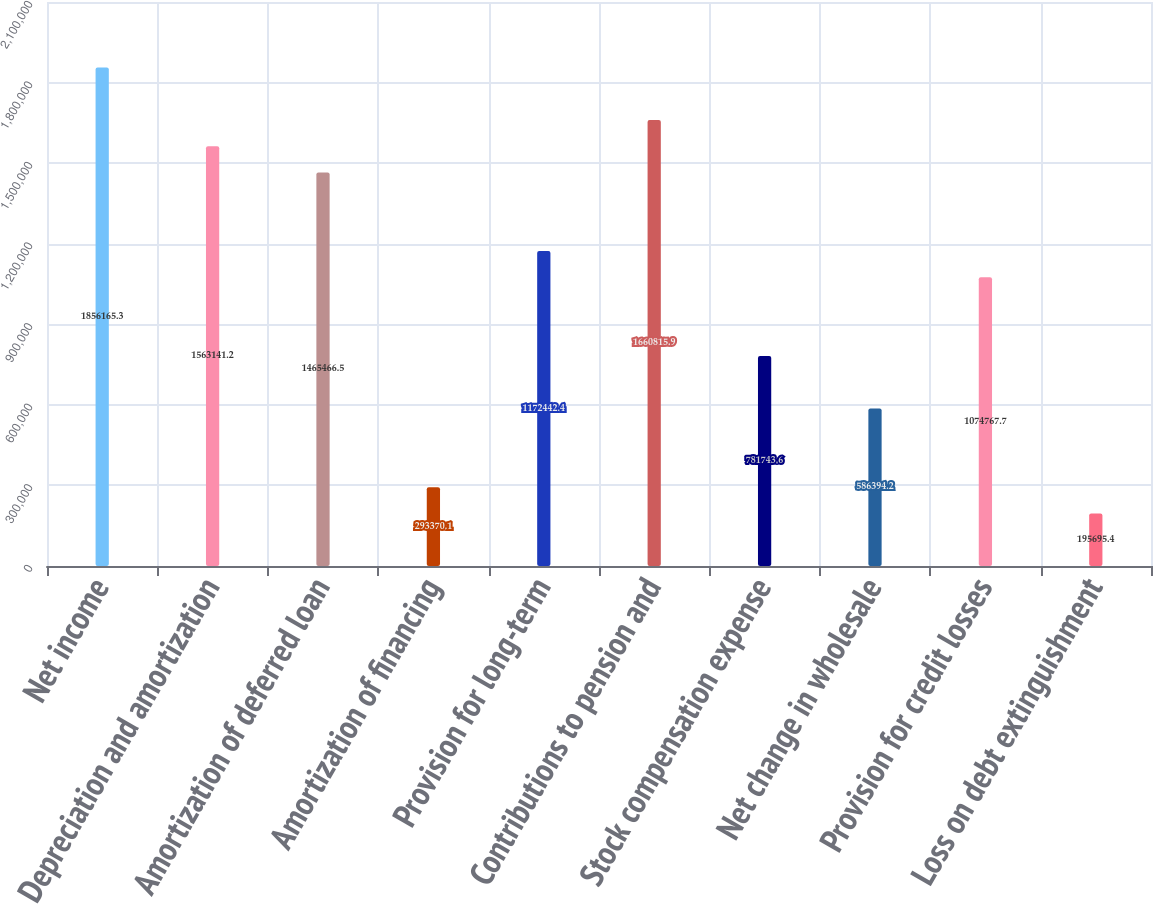Convert chart to OTSL. <chart><loc_0><loc_0><loc_500><loc_500><bar_chart><fcel>Net income<fcel>Depreciation and amortization<fcel>Amortization of deferred loan<fcel>Amortization of financing<fcel>Provision for long-term<fcel>Contributions to pension and<fcel>Stock compensation expense<fcel>Net change in wholesale<fcel>Provision for credit losses<fcel>Loss on debt extinguishment<nl><fcel>1.85617e+06<fcel>1.56314e+06<fcel>1.46547e+06<fcel>293370<fcel>1.17244e+06<fcel>1.66082e+06<fcel>781744<fcel>586394<fcel>1.07477e+06<fcel>195695<nl></chart> 